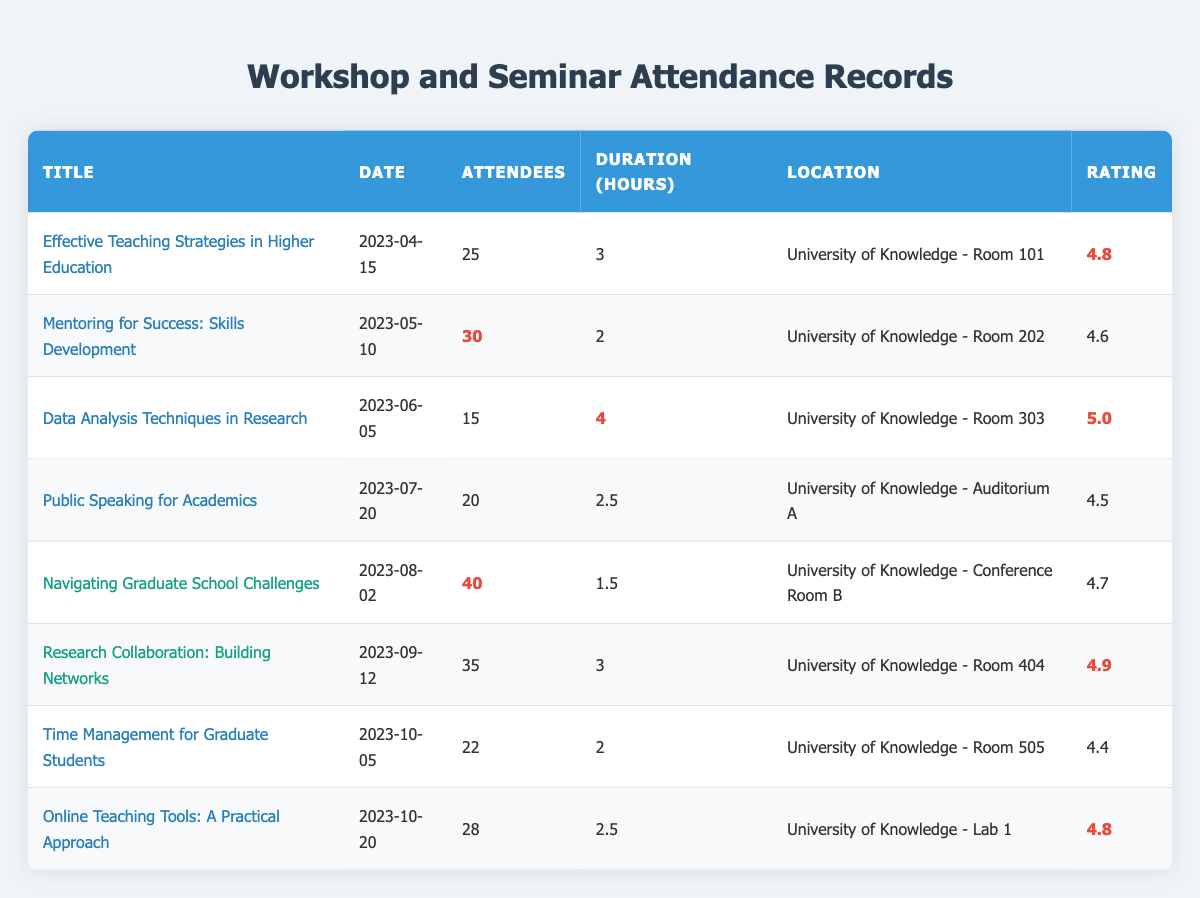What is the title of the workshop held on April 15, 2023? The table lists the date and corresponding titles. On April 15, 2023, the workshop titled "Effective Teaching Strategies in Higher Education" is recorded.
Answer: Effective Teaching Strategies in Higher Education How many attendees participated in the seminar "Research Collaboration: Building Networks"? The table has a row for the seminar titled "Research Collaboration: Building Networks," which shows that 35 attendees participated.
Answer: 35 What was the highest rating received for any workshop? By examining the ratings for all workshops listed, "Data Analysis Techniques in Research" received the highest rating of 5.0.
Answer: 5.0 Which event had the longest duration in hours? The table reveals that "Data Analysis Techniques in Research" had a duration of 4 hours, which is longer than any other listed event.
Answer: 4 hours What is the total number of attendees for all workshops held on dates in April through August? By summing the attendees from April (25), May (30), June (15), July (20), and August (40), we get 25 + 30 + 15 + 20 + 40 = 130.
Answer: 130 Is the rating for "Public Speaking for Academics" higher than 4.5? The rating for "Public Speaking for Academics" is 4.5; thus, it is not higher than 4.5.
Answer: No What is the average rating of all workshops listed? The ratings to average are 4.8, 4.6, 5.0, 4.5, 4.4, and 4.8. Summing these gives 28.1, and since there are 6 workshops, the average is 28.1 / 6 = 4.6833, which can be rounded to 4.7.
Answer: 4.7 How many events had more than 30 attendees? By reviewing the attendee numbers, the events with more than 30 attendees are the "Navigating Graduate School Challenges" (40) and the "Research Collaboration: Building Networks" (35). Hence, there are 2 events with over 30 attendees.
Answer: 2 Which location hosted the seminar "Navigating Graduate School Challenges"? The seminar "Navigating Graduate School Challenges" is listed as being held at "University of Knowledge - Conference Room B".
Answer: University of Knowledge - Conference Room B What is the difference in attendees between the seminar with the highest attendance and the workshop with the least? The seminar with the highest attendance is "Navigating Graduate School Challenges" with 40 attendees, while the workshop with the least is "Data Analysis Techniques in Research" with 15 attendees. The difference is 40 - 15 = 25.
Answer: 25 